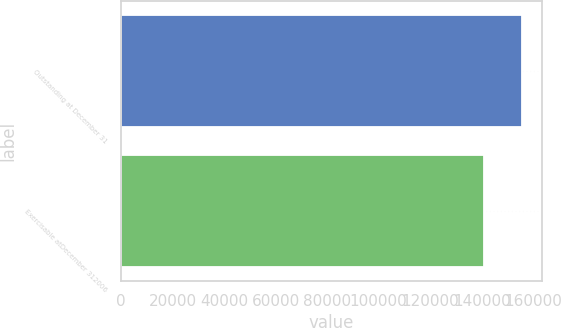<chart> <loc_0><loc_0><loc_500><loc_500><bar_chart><fcel>Outstanding at December 31<fcel>Exercisable atDecember 312006<nl><fcel>155715<fcel>140829<nl></chart> 